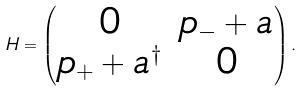Convert formula to latex. <formula><loc_0><loc_0><loc_500><loc_500>H = \begin{pmatrix} 0 & p _ { - } + a \\ p _ { + } + a ^ { \dagger } & 0 \end{pmatrix} .</formula> 